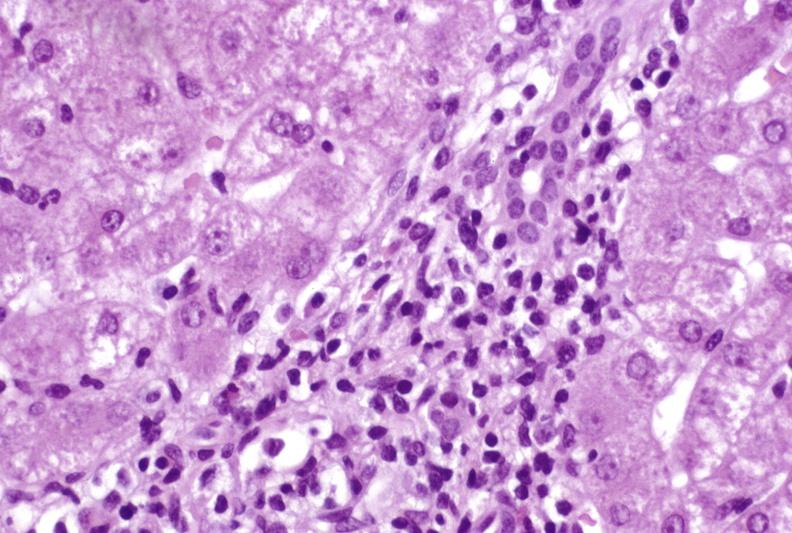does bone, skull show moderate acute rejection?
Answer the question using a single word or phrase. No 